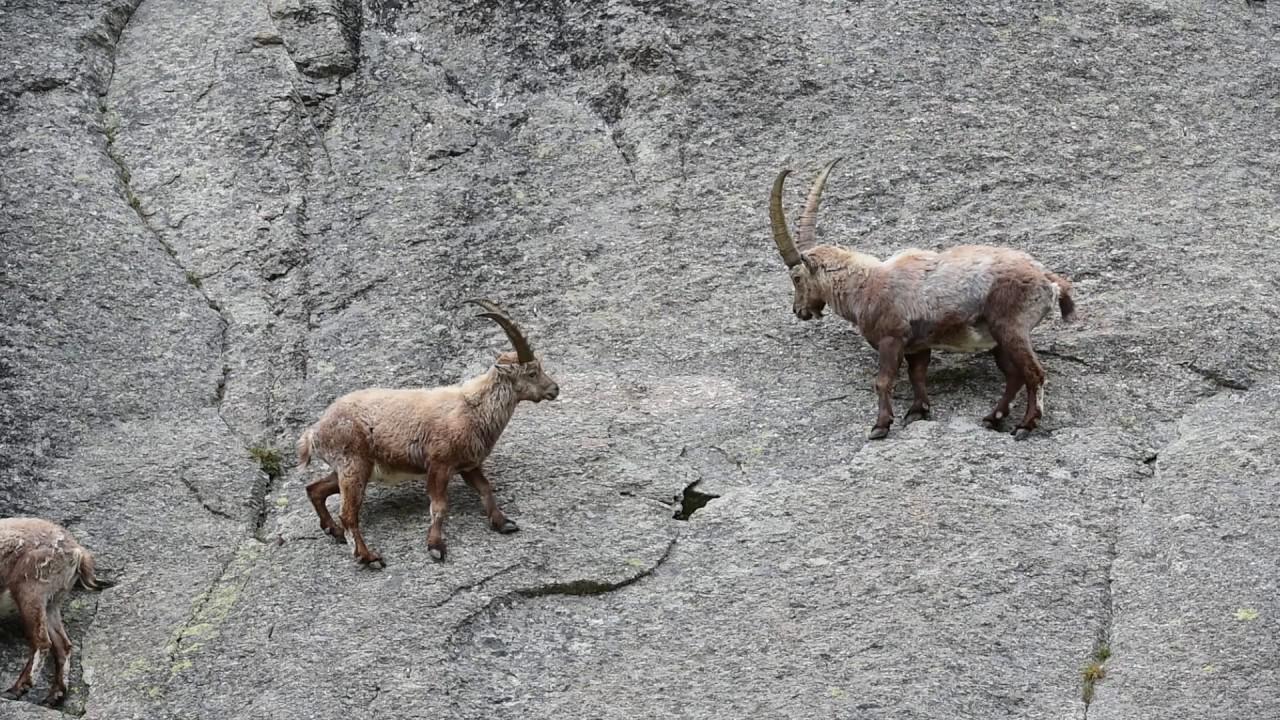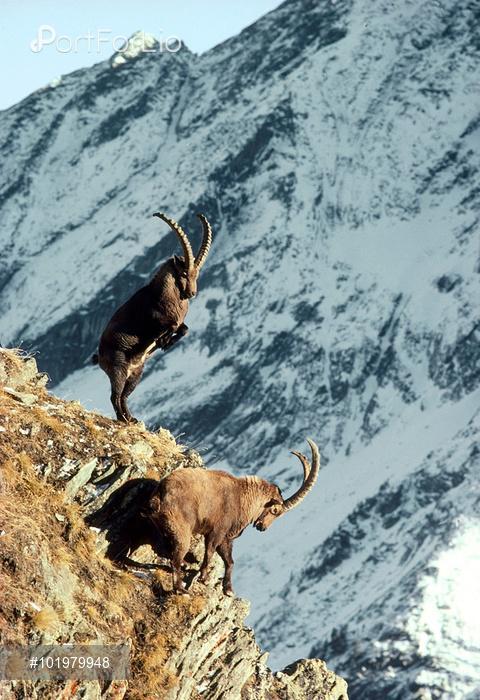The first image is the image on the left, the second image is the image on the right. For the images shown, is this caption "The right photo contains three or more animals." true? Answer yes or no. No. 